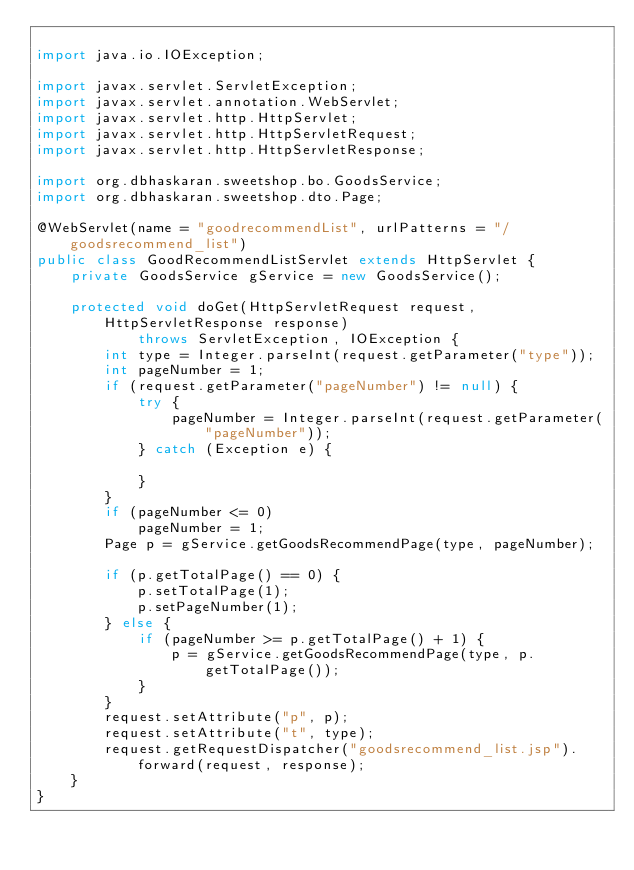Convert code to text. <code><loc_0><loc_0><loc_500><loc_500><_Java_>
import java.io.IOException;

import javax.servlet.ServletException;
import javax.servlet.annotation.WebServlet;
import javax.servlet.http.HttpServlet;
import javax.servlet.http.HttpServletRequest;
import javax.servlet.http.HttpServletResponse;

import org.dbhaskaran.sweetshop.bo.GoodsService;
import org.dbhaskaran.sweetshop.dto.Page;

@WebServlet(name = "goodrecommendList", urlPatterns = "/goodsrecommend_list")
public class GoodRecommendListServlet extends HttpServlet {
	private GoodsService gService = new GoodsService();

	protected void doGet(HttpServletRequest request, HttpServletResponse response)
			throws ServletException, IOException {
		int type = Integer.parseInt(request.getParameter("type"));
		int pageNumber = 1;
		if (request.getParameter("pageNumber") != null) {
			try {
				pageNumber = Integer.parseInt(request.getParameter("pageNumber"));
			} catch (Exception e) {

			}
		}
		if (pageNumber <= 0)
			pageNumber = 1;
		Page p = gService.getGoodsRecommendPage(type, pageNumber);

		if (p.getTotalPage() == 0) {
			p.setTotalPage(1);
			p.setPageNumber(1);
		} else {
			if (pageNumber >= p.getTotalPage() + 1) {
				p = gService.getGoodsRecommendPage(type, p.getTotalPage());
			}
		}
		request.setAttribute("p", p);
		request.setAttribute("t", type);
		request.getRequestDispatcher("goodsrecommend_list.jsp").forward(request, response);
	}
}
</code> 